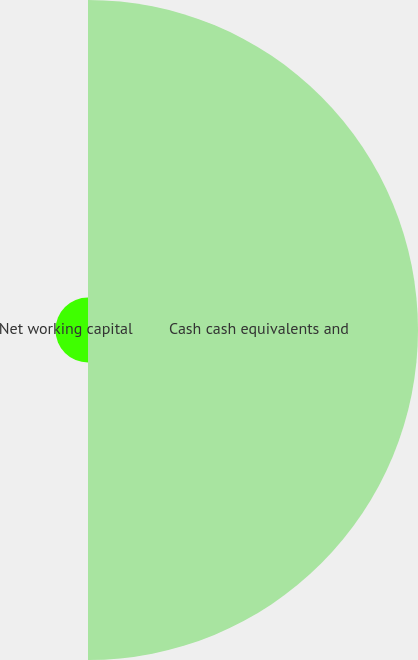Convert chart. <chart><loc_0><loc_0><loc_500><loc_500><pie_chart><fcel>Cash cash equivalents and<fcel>Net working capital<nl><fcel>91.03%<fcel>8.97%<nl></chart> 